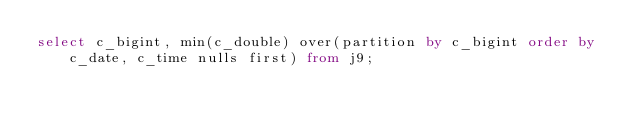<code> <loc_0><loc_0><loc_500><loc_500><_SQL_>select c_bigint, min(c_double) over(partition by c_bigint order by c_date, c_time nulls first) from j9;
</code> 